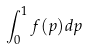Convert formula to latex. <formula><loc_0><loc_0><loc_500><loc_500>\int _ { 0 } ^ { 1 } f ( p ) d p</formula> 